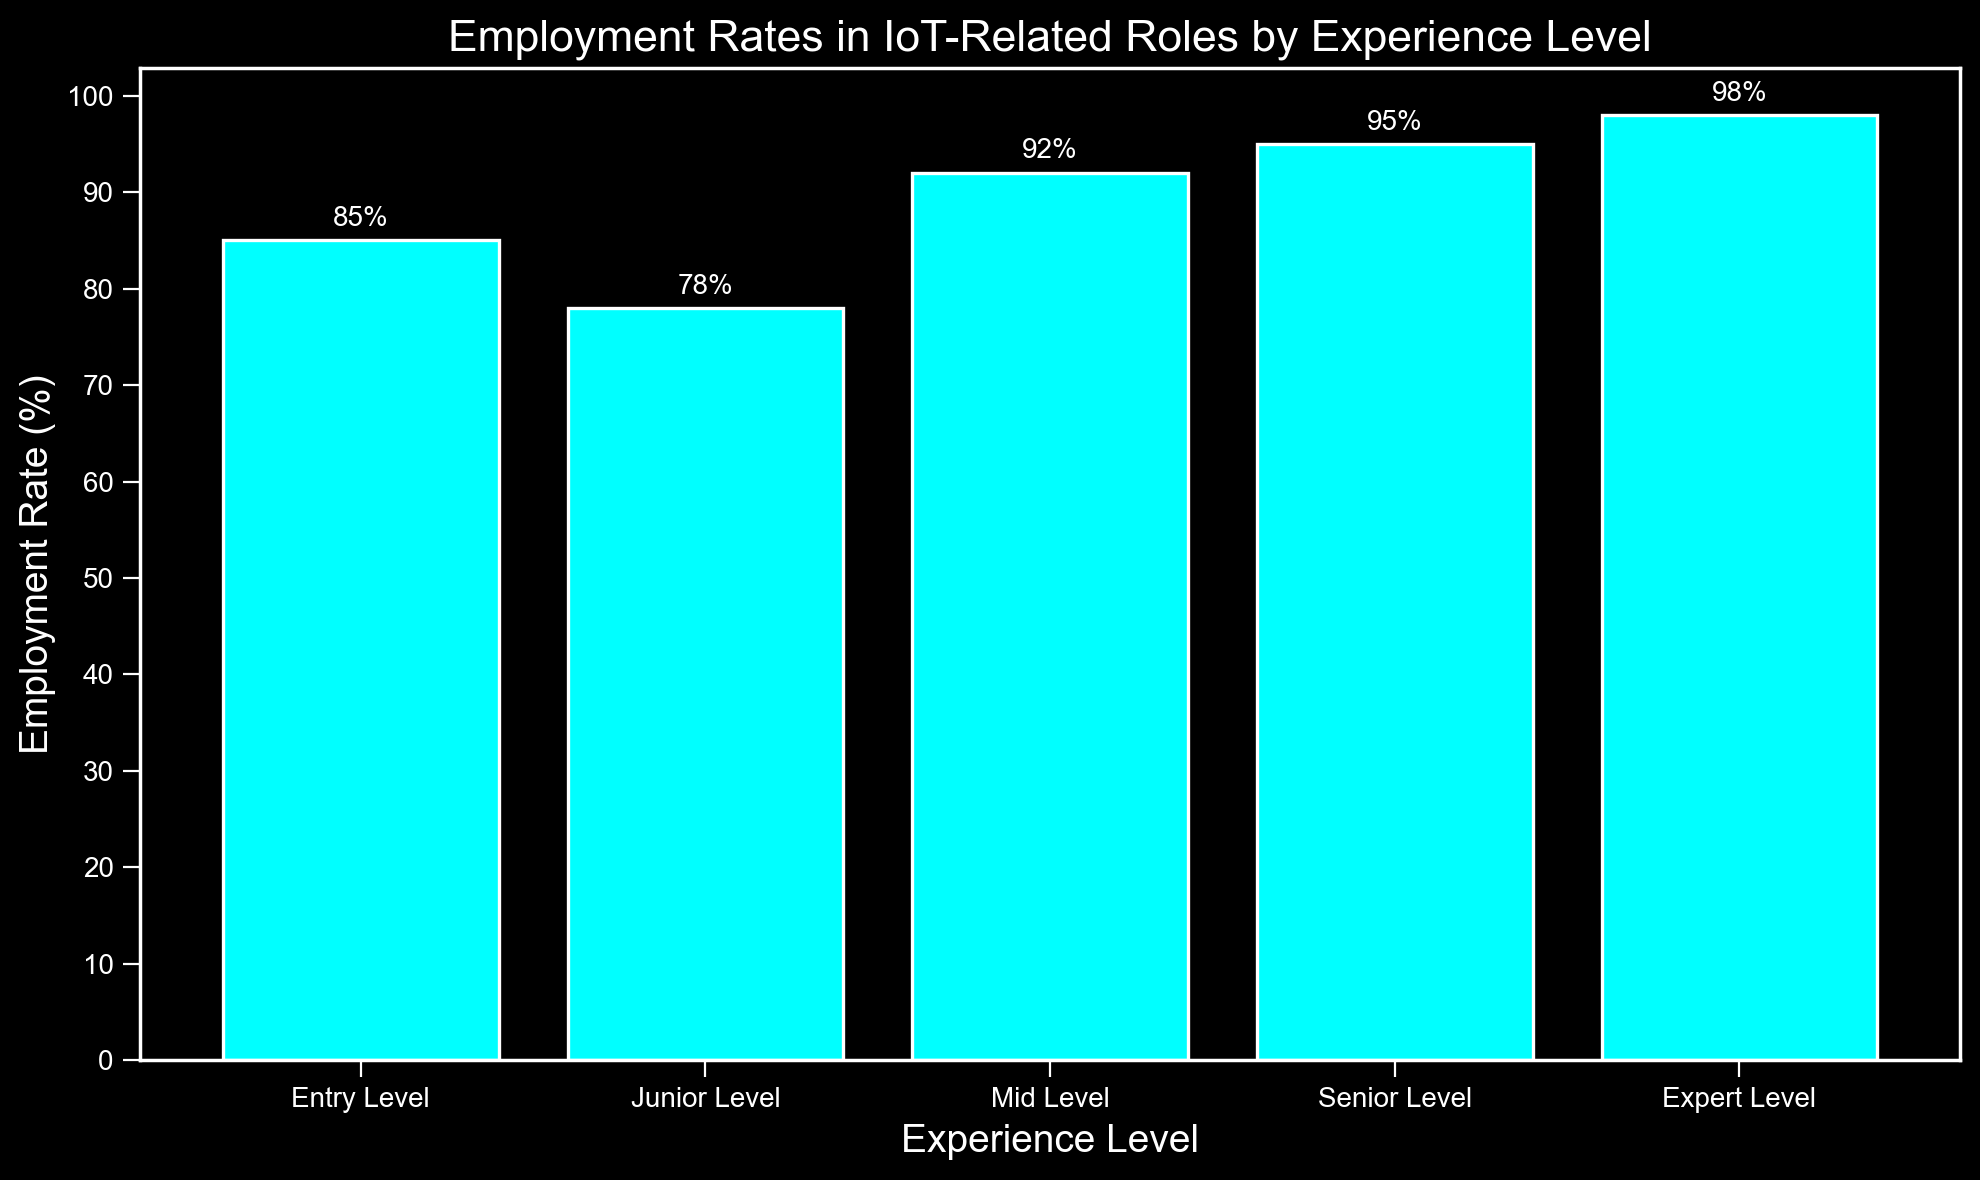What's the employment rate for Entry Level positions? Look at the bar labeled "Entry Level" in the figure. The number annotated on the top of the bar is the employment rate for that category. It's listed as 85%.
Answer: 85% Which experience level has the highest employment rate? Compare the heights and the numbers annotated on top of each bar. The highest number is 98% for the "Expert Level" bar.
Answer: Expert Level Is the employment rate for Junior Level positions higher or lower than Mid Level positions? Check the numbers annotated on top of the "Junior Level" and "Mid Level" bars. Junior Level is 78% and Mid Level is 92%, so Junior Level is lower.
Answer: Lower How much is the difference in employment rates between Senior Level and Entry Level? Look at the numbers for Senior Level (95%) and Entry Level (85%). The difference is calculated as 95 - 85 = 10.
Answer: 10% What is the average employment rate across all experience levels? Sum the employment rates (85 + 78 + 92 + 95 + 98) which equals 448, then divide by the number of levels (5). So, the average is 448/5 = 89.6%
Answer: 89.6% Which experience levels have employment rates above 90%? Identify the bars with numbers above 90%. Mid Level (92%), Senior Level (95%), and Expert Level (98%) are all above 90%.
Answer: Mid Level, Senior Level, Expert Level How much taller is the Expert Level bar compared to the Junior Level bar? Expert Level is 98% and Junior Level is 78%. The difference is 98 - 78 = 20. So the Expert Level bar is 20 percentage points taller.
Answer: 20 What percentage of employment rates is below 80%? Only the Junior Level has an employment rate below 80%, which is 78%. The percentage for this level based on the total levels (5) is calculated as (1/5) * 100 = 20%.
Answer: 20% Rank the experience levels from lowest to highest employment rate. From the numbers annotated: Junior Level (78%), Entry Level (85%), Mid Level (92%), Senior Level (95%), Expert Level (98%). So, the ranking is: Junior Level, Entry Level, Mid Level, Senior Level, Expert Level.
Answer: Junior Level, Entry Level, Mid Level, Senior Level, Expert Level What is the employment rate for levels above Mid Level? Mid Level has an employment rate of 92%, so look at levels above it: Senior Level at 95% and Expert Level at 98%. The average of these two is (95+98)/2 = 96.5%.
Answer: 96.5% 